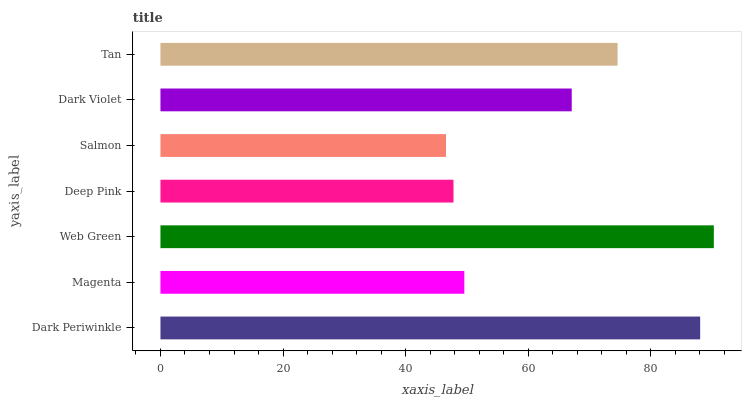Is Salmon the minimum?
Answer yes or no. Yes. Is Web Green the maximum?
Answer yes or no. Yes. Is Magenta the minimum?
Answer yes or no. No. Is Magenta the maximum?
Answer yes or no. No. Is Dark Periwinkle greater than Magenta?
Answer yes or no. Yes. Is Magenta less than Dark Periwinkle?
Answer yes or no. Yes. Is Magenta greater than Dark Periwinkle?
Answer yes or no. No. Is Dark Periwinkle less than Magenta?
Answer yes or no. No. Is Dark Violet the high median?
Answer yes or no. Yes. Is Dark Violet the low median?
Answer yes or no. Yes. Is Web Green the high median?
Answer yes or no. No. Is Dark Periwinkle the low median?
Answer yes or no. No. 